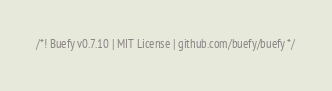<code> <loc_0><loc_0><loc_500><loc_500><_JavaScript_>/*! Buefy v0.7.10 | MIT License | github.com/buefy/buefy */</code> 